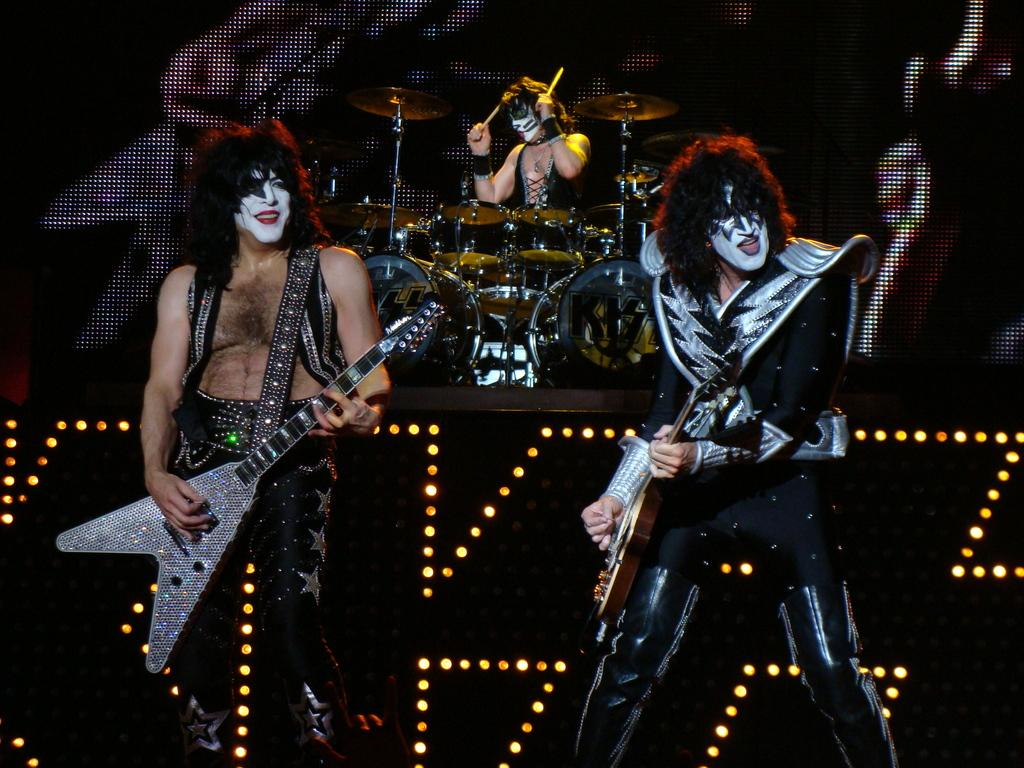What are the two persons on the stage doing? The two persons on the stage are playing guitar. Is there anyone else on the stage with them? Yes, there is a person playing drums behind the guitarists. How many chairs are visible on the stage? There are no chairs visible on the stage in the image. What type of play is being performed by the family on the stage? There is no family present in the image, and no play is being performed; it is a musical performance with guitarists and a drummer. 